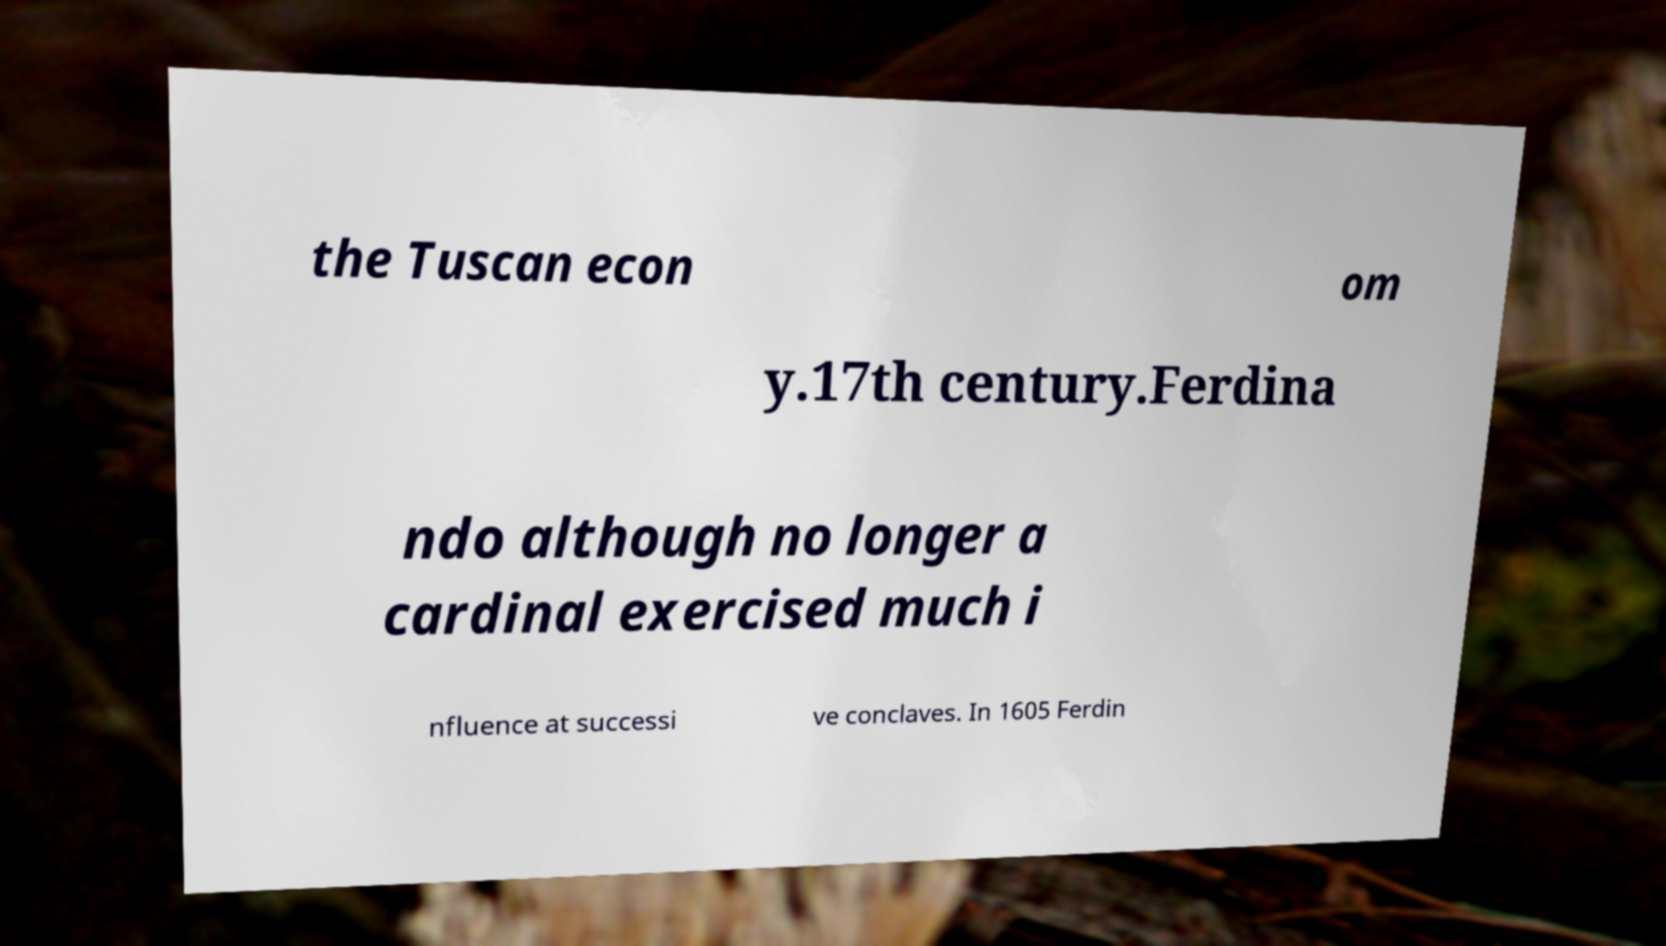Please read and relay the text visible in this image. What does it say? the Tuscan econ om y.17th century.Ferdina ndo although no longer a cardinal exercised much i nfluence at successi ve conclaves. In 1605 Ferdin 